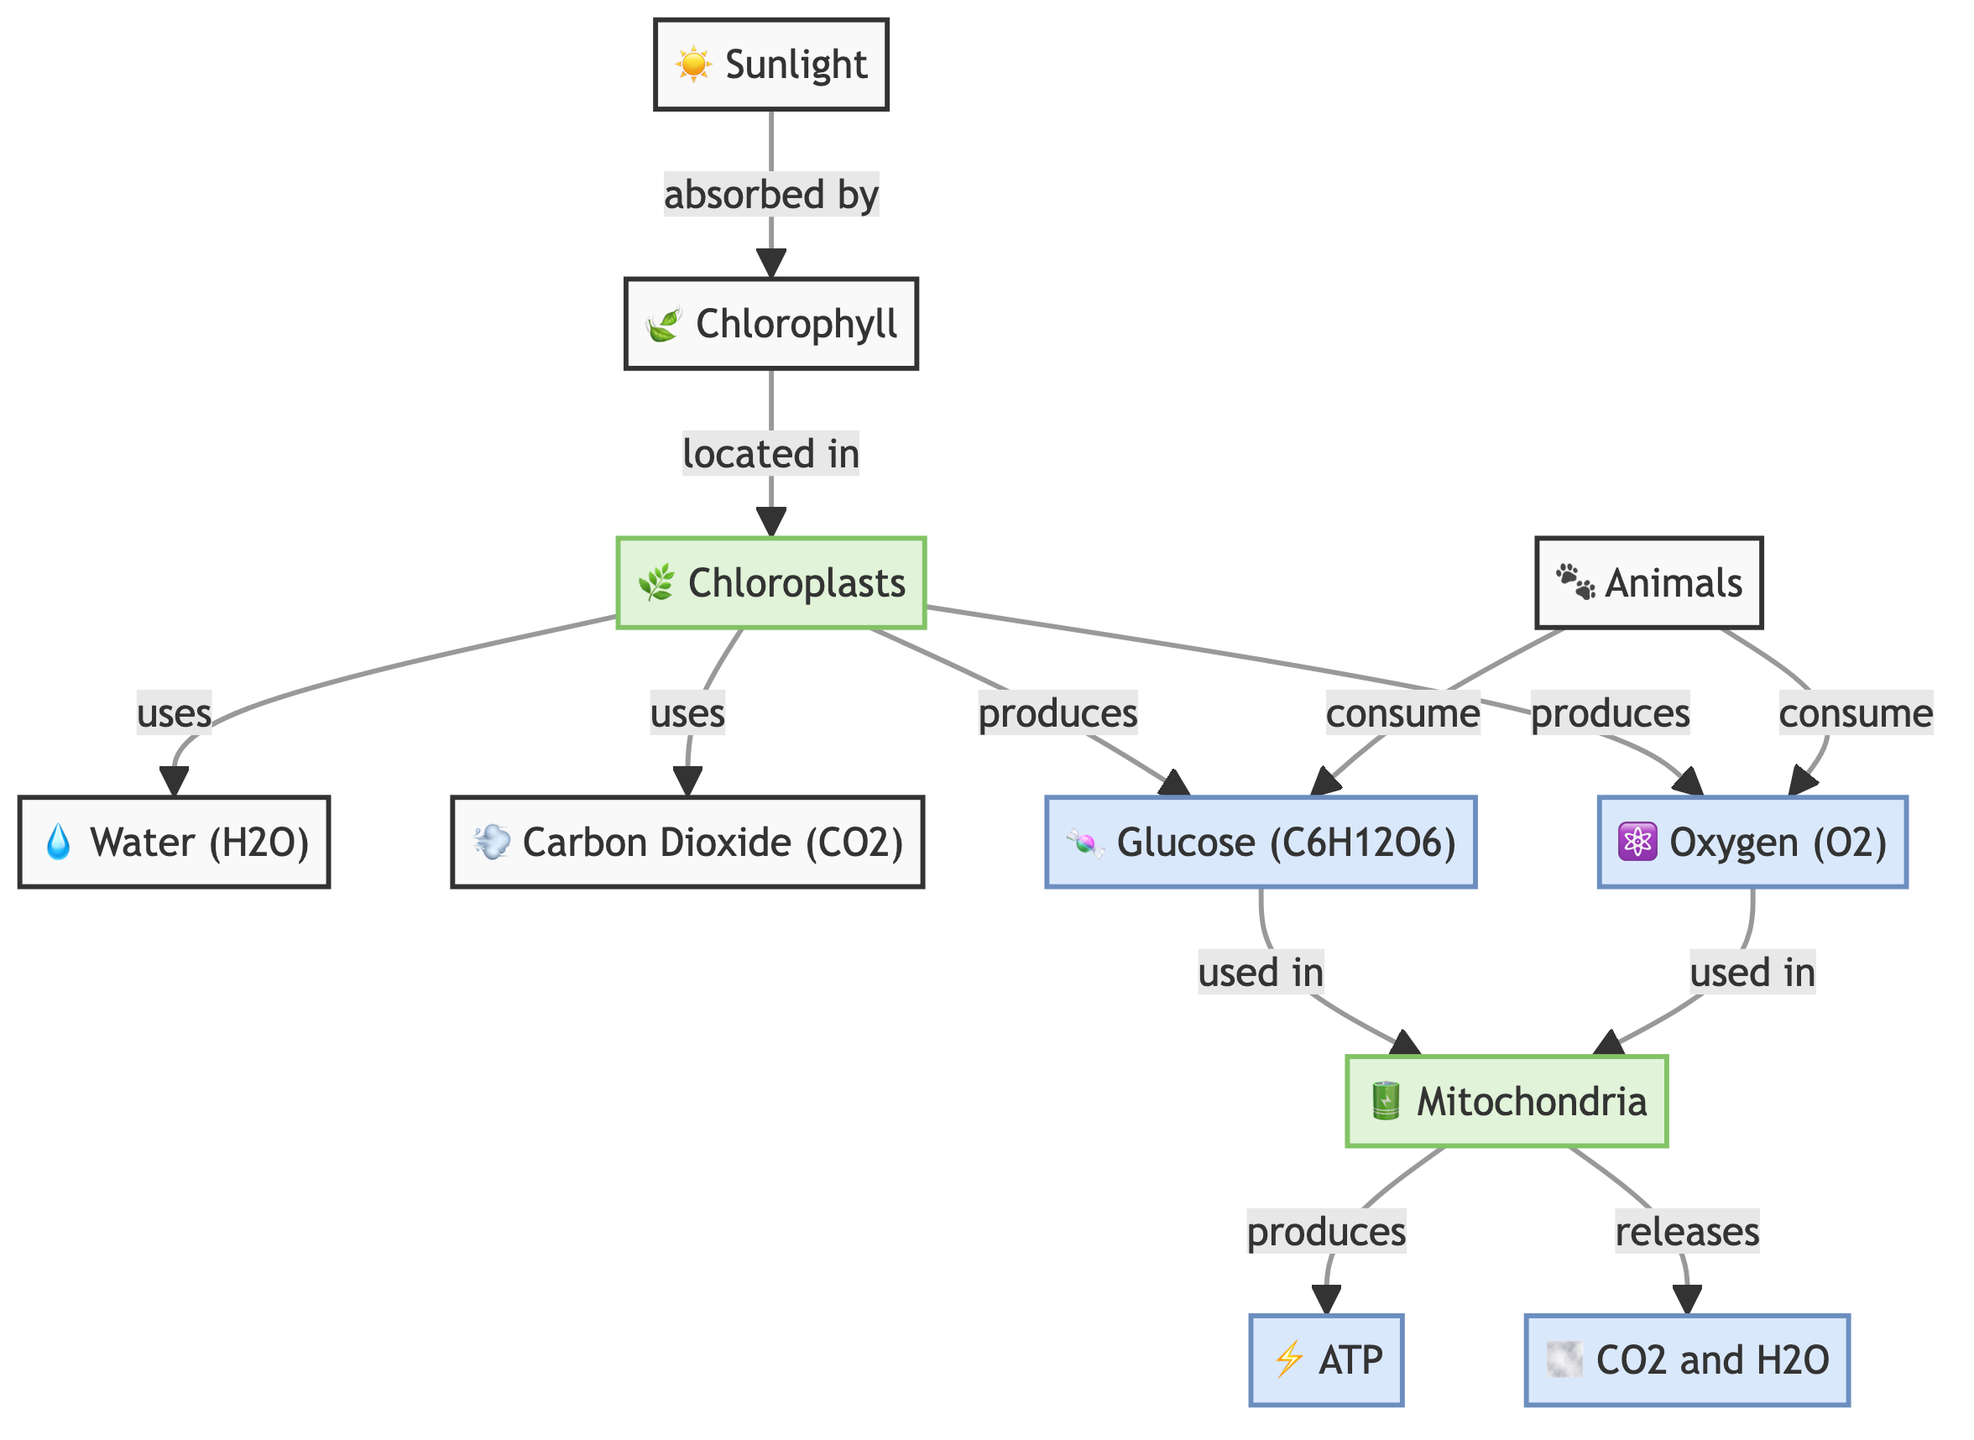What is produced by chloroplasts during photosynthesis? The diagram indicates that chloroplasts produce glucose and oxygen as products of photosynthesis. These products are shown as arrows leading from the chloroplasts to the respective nodes.
Answer: glucose and oxygen How many main inputs are used in the process of photosynthesis? The diagram lists water and carbon dioxide as the two main inputs used by chloroplasts during photosynthesis. Therefore, there are two inputs identified.
Answer: 2 Which organelle is responsible for ATP production? The diagram clearly shows that mitochondria are responsible for producing ATP after utilizing glucose and oxygen, as indicated by the flow of arrows and labels.
Answer: mitochondria What do animals consume according to the diagram? The diagram indicates that animals consume both glucose and oxygen as part of the cellular respiration process, with arrows showing consumption directed towards animals.
Answer: glucose and oxygen Which substances are released by mitochondria during cellular respiration? According to the diagram, mitochondria release carbon dioxide and water as byproducts of cellular respiration, as shown by the arrows pointing to the CO2 and H2O node.
Answer: CO2 and H2O What role does chlorophyll play in photosynthesis? The diagram shows that chlorophyll absorbs sunlight, which is a key step in the process of photosynthesis that takes place in chloroplasts, allowing them to produce glucose and oxygen.
Answer: absorbs sunlight How do plants and animals exchange energy in the diagram? The diagram illustrates that plants use sunlight to create glucose and oxygen through photosynthesis, while animals consume these products to generate ATP in mitochondria, thereby establishing an energy exchange.
Answer: through photosynthesis and respiration What does the arrow from glucose to mitochondria indicate? The arrow indicating the flow from glucose to mitochondria signifies that glucose is utilized in mitochondria to produce ATP, which is a critical part of cellular respiration.
Answer: utilization for ATP production 